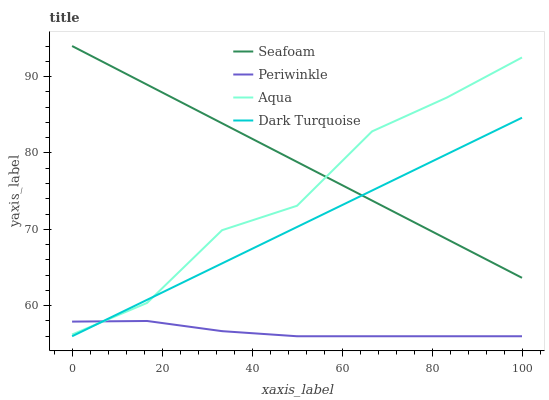Does Periwinkle have the minimum area under the curve?
Answer yes or no. Yes. Does Seafoam have the maximum area under the curve?
Answer yes or no. Yes. Does Seafoam have the minimum area under the curve?
Answer yes or no. No. Does Periwinkle have the maximum area under the curve?
Answer yes or no. No. Is Dark Turquoise the smoothest?
Answer yes or no. Yes. Is Aqua the roughest?
Answer yes or no. Yes. Is Periwinkle the smoothest?
Answer yes or no. No. Is Periwinkle the roughest?
Answer yes or no. No. Does Periwinkle have the lowest value?
Answer yes or no. Yes. Does Seafoam have the lowest value?
Answer yes or no. No. Does Seafoam have the highest value?
Answer yes or no. Yes. Does Periwinkle have the highest value?
Answer yes or no. No. Is Periwinkle less than Seafoam?
Answer yes or no. Yes. Is Seafoam greater than Periwinkle?
Answer yes or no. Yes. Does Seafoam intersect Dark Turquoise?
Answer yes or no. Yes. Is Seafoam less than Dark Turquoise?
Answer yes or no. No. Is Seafoam greater than Dark Turquoise?
Answer yes or no. No. Does Periwinkle intersect Seafoam?
Answer yes or no. No. 